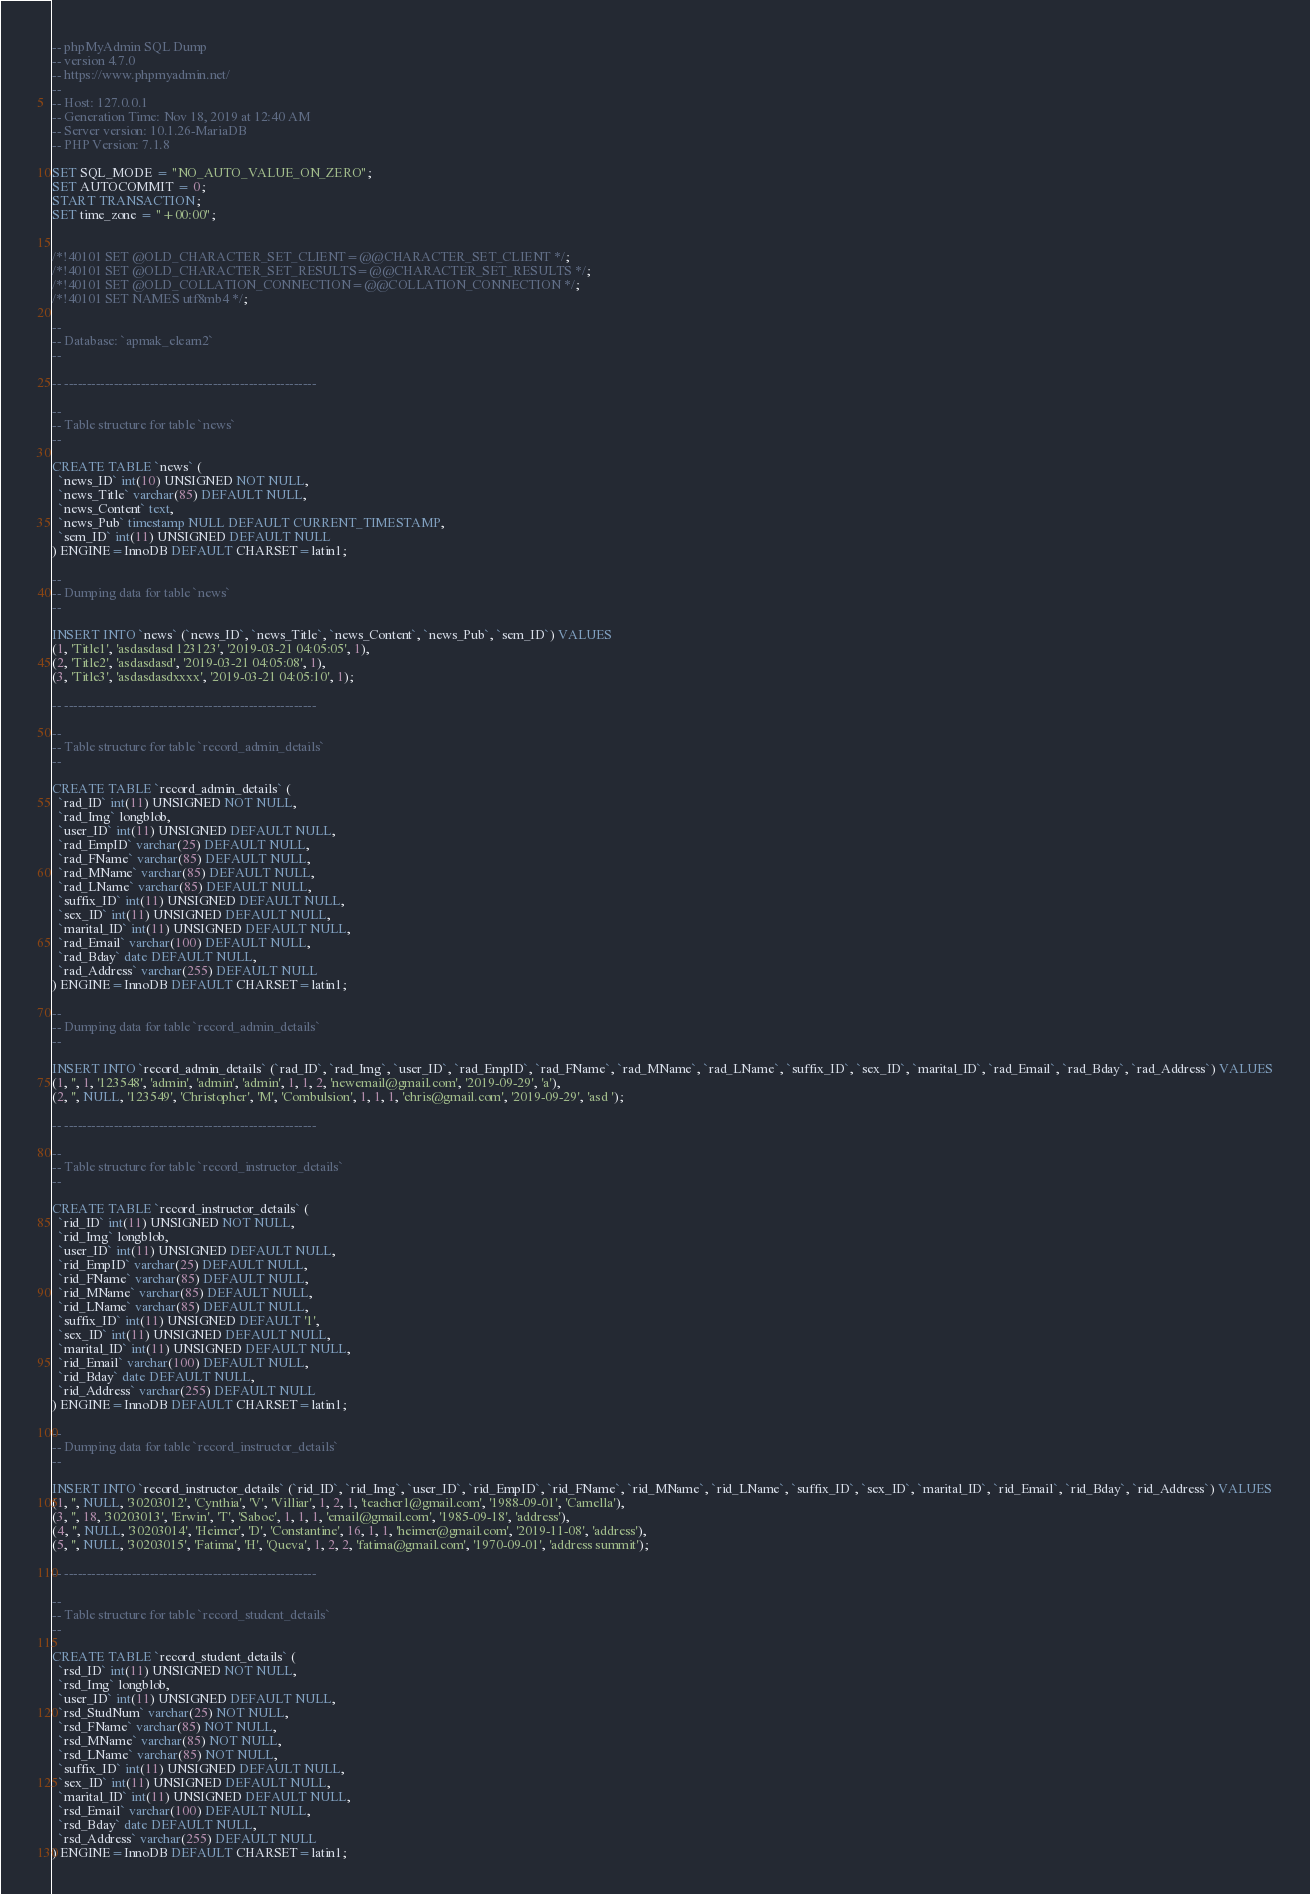Convert code to text. <code><loc_0><loc_0><loc_500><loc_500><_SQL_>-- phpMyAdmin SQL Dump
-- version 4.7.0
-- https://www.phpmyadmin.net/
--
-- Host: 127.0.0.1
-- Generation Time: Nov 18, 2019 at 12:40 AM
-- Server version: 10.1.26-MariaDB
-- PHP Version: 7.1.8

SET SQL_MODE = "NO_AUTO_VALUE_ON_ZERO";
SET AUTOCOMMIT = 0;
START TRANSACTION;
SET time_zone = "+00:00";


/*!40101 SET @OLD_CHARACTER_SET_CLIENT=@@CHARACTER_SET_CLIENT */;
/*!40101 SET @OLD_CHARACTER_SET_RESULTS=@@CHARACTER_SET_RESULTS */;
/*!40101 SET @OLD_COLLATION_CONNECTION=@@COLLATION_CONNECTION */;
/*!40101 SET NAMES utf8mb4 */;

--
-- Database: `apmak_elearn2`
--

-- --------------------------------------------------------

--
-- Table structure for table `news`
--

CREATE TABLE `news` (
  `news_ID` int(10) UNSIGNED NOT NULL,
  `news_Title` varchar(85) DEFAULT NULL,
  `news_Content` text,
  `news_Pub` timestamp NULL DEFAULT CURRENT_TIMESTAMP,
  `sem_ID` int(11) UNSIGNED DEFAULT NULL
) ENGINE=InnoDB DEFAULT CHARSET=latin1;

--
-- Dumping data for table `news`
--

INSERT INTO `news` (`news_ID`, `news_Title`, `news_Content`, `news_Pub`, `sem_ID`) VALUES
(1, 'Title1', 'asdasdasd 123123', '2019-03-21 04:05:05', 1),
(2, 'Title2', 'asdasdasd', '2019-03-21 04:05:08', 1),
(3, 'Title3', 'asdasdasdxxxx', '2019-03-21 04:05:10', 1);

-- --------------------------------------------------------

--
-- Table structure for table `record_admin_details`
--

CREATE TABLE `record_admin_details` (
  `rad_ID` int(11) UNSIGNED NOT NULL,
  `rad_Img` longblob,
  `user_ID` int(11) UNSIGNED DEFAULT NULL,
  `rad_EmpID` varchar(25) DEFAULT NULL,
  `rad_FName` varchar(85) DEFAULT NULL,
  `rad_MName` varchar(85) DEFAULT NULL,
  `rad_LName` varchar(85) DEFAULT NULL,
  `suffix_ID` int(11) UNSIGNED DEFAULT NULL,
  `sex_ID` int(11) UNSIGNED DEFAULT NULL,
  `marital_ID` int(11) UNSIGNED DEFAULT NULL,
  `rad_Email` varchar(100) DEFAULT NULL,
  `rad_Bday` date DEFAULT NULL,
  `rad_Address` varchar(255) DEFAULT NULL
) ENGINE=InnoDB DEFAULT CHARSET=latin1;

--
-- Dumping data for table `record_admin_details`
--

INSERT INTO `record_admin_details` (`rad_ID`, `rad_Img`, `user_ID`, `rad_EmpID`, `rad_FName`, `rad_MName`, `rad_LName`, `suffix_ID`, `sex_ID`, `marital_ID`, `rad_Email`, `rad_Bday`, `rad_Address`) VALUES
(1, '', 1, '123548', 'admin', 'admin', 'admin', 1, 1, 2, 'newemail@gmail.com', '2019-09-29', 'a'),
(2, '', NULL, '123549', 'Christopher', 'M', 'Combulsion', 1, 1, 1, 'chris@gmail.com', '2019-09-29', 'asd ');

-- --------------------------------------------------------

--
-- Table structure for table `record_instructor_details`
--

CREATE TABLE `record_instructor_details` (
  `rid_ID` int(11) UNSIGNED NOT NULL,
  `rid_Img` longblob,
  `user_ID` int(11) UNSIGNED DEFAULT NULL,
  `rid_EmpID` varchar(25) DEFAULT NULL,
  `rid_FName` varchar(85) DEFAULT NULL,
  `rid_MName` varchar(85) DEFAULT NULL,
  `rid_LName` varchar(85) DEFAULT NULL,
  `suffix_ID` int(11) UNSIGNED DEFAULT '1',
  `sex_ID` int(11) UNSIGNED DEFAULT NULL,
  `marital_ID` int(11) UNSIGNED DEFAULT NULL,
  `rid_Email` varchar(100) DEFAULT NULL,
  `rid_Bday` date DEFAULT NULL,
  `rid_Address` varchar(255) DEFAULT NULL
) ENGINE=InnoDB DEFAULT CHARSET=latin1;

--
-- Dumping data for table `record_instructor_details`
--

INSERT INTO `record_instructor_details` (`rid_ID`, `rid_Img`, `user_ID`, `rid_EmpID`, `rid_FName`, `rid_MName`, `rid_LName`, `suffix_ID`, `sex_ID`, `marital_ID`, `rid_Email`, `rid_Bday`, `rid_Address`) VALUES
(1, '', NULL, '30203012', 'Cynthia', 'V', 'Villiar', 1, 2, 1, 'teacher1@gmail.com', '1988-09-01', 'Camella'),
(3, '', 18, '30203013', 'Erwin', 'T', 'Saboc', 1, 1, 1, 'email@gmail.com', '1985-09-18', 'address'),
(4, '', NULL, '30203014', 'Heimer', 'D', 'Constantine', 16, 1, 1, 'heimer@gmail.com', '2019-11-08', 'address'),
(5, '', NULL, '30203015', 'Fatima', 'H', 'Queva', 1, 2, 2, 'fatima@gmail.com', '1970-09-01', 'address summit');

-- --------------------------------------------------------

--
-- Table structure for table `record_student_details`
--

CREATE TABLE `record_student_details` (
  `rsd_ID` int(11) UNSIGNED NOT NULL,
  `rsd_Img` longblob,
  `user_ID` int(11) UNSIGNED DEFAULT NULL,
  `rsd_StudNum` varchar(25) NOT NULL,
  `rsd_FName` varchar(85) NOT NULL,
  `rsd_MName` varchar(85) NOT NULL,
  `rsd_LName` varchar(85) NOT NULL,
  `suffix_ID` int(11) UNSIGNED DEFAULT NULL,
  `sex_ID` int(11) UNSIGNED DEFAULT NULL,
  `marital_ID` int(11) UNSIGNED DEFAULT NULL,
  `rsd_Email` varchar(100) DEFAULT NULL,
  `rsd_Bday` date DEFAULT NULL,
  `rsd_Address` varchar(255) DEFAULT NULL
) ENGINE=InnoDB DEFAULT CHARSET=latin1;
</code> 